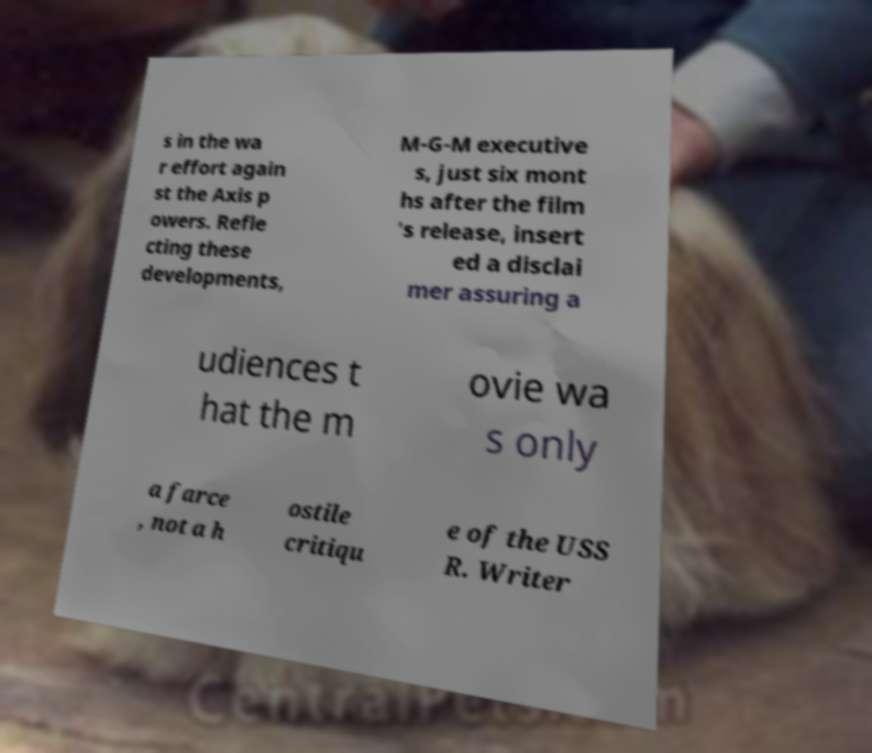For documentation purposes, I need the text within this image transcribed. Could you provide that? s in the wa r effort again st the Axis p owers. Refle cting these developments, M-G-M executive s, just six mont hs after the film 's release, insert ed a disclai mer assuring a udiences t hat the m ovie wa s only a farce , not a h ostile critiqu e of the USS R. Writer 